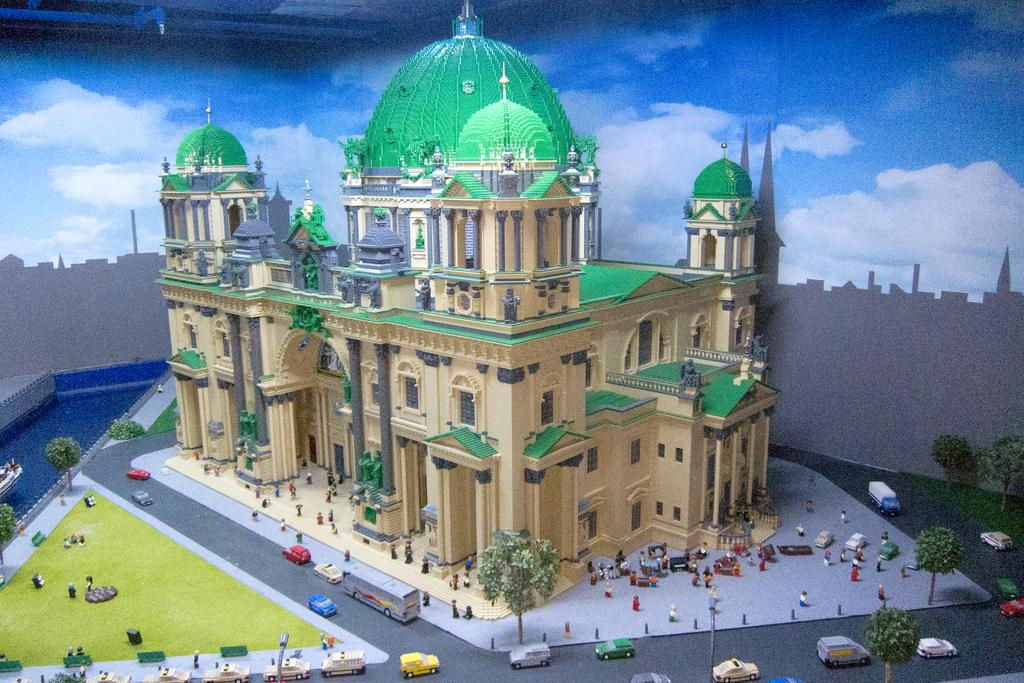What type of building is shown in the image? There is a palace in the image. What can be seen in the image besides the palace? There are roads in the image. What type of tree can be seen growing in the palace? There is no tree visible in the image; it only shows a palace and roads. 